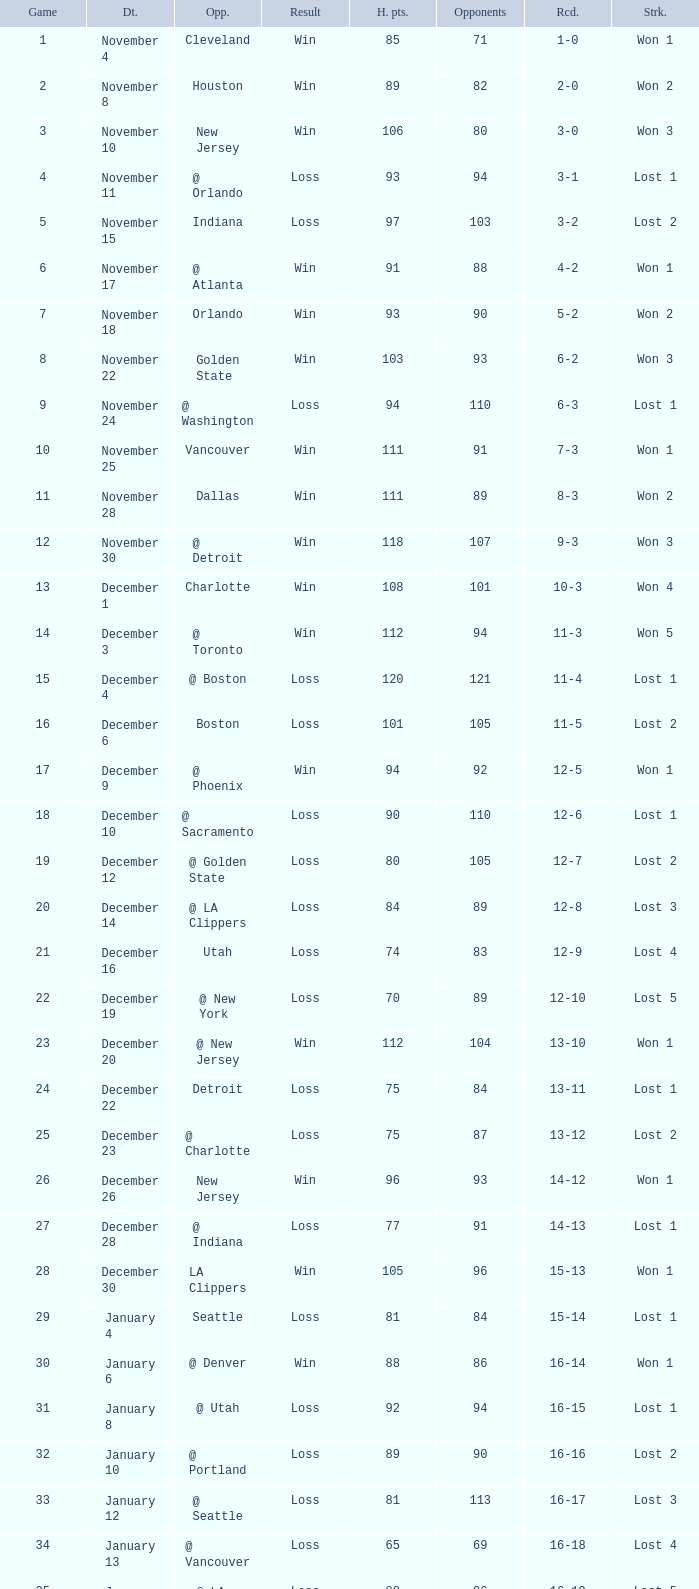What is Streak, when Heat Points is "101", and when Game is "16"? Lost 2. 